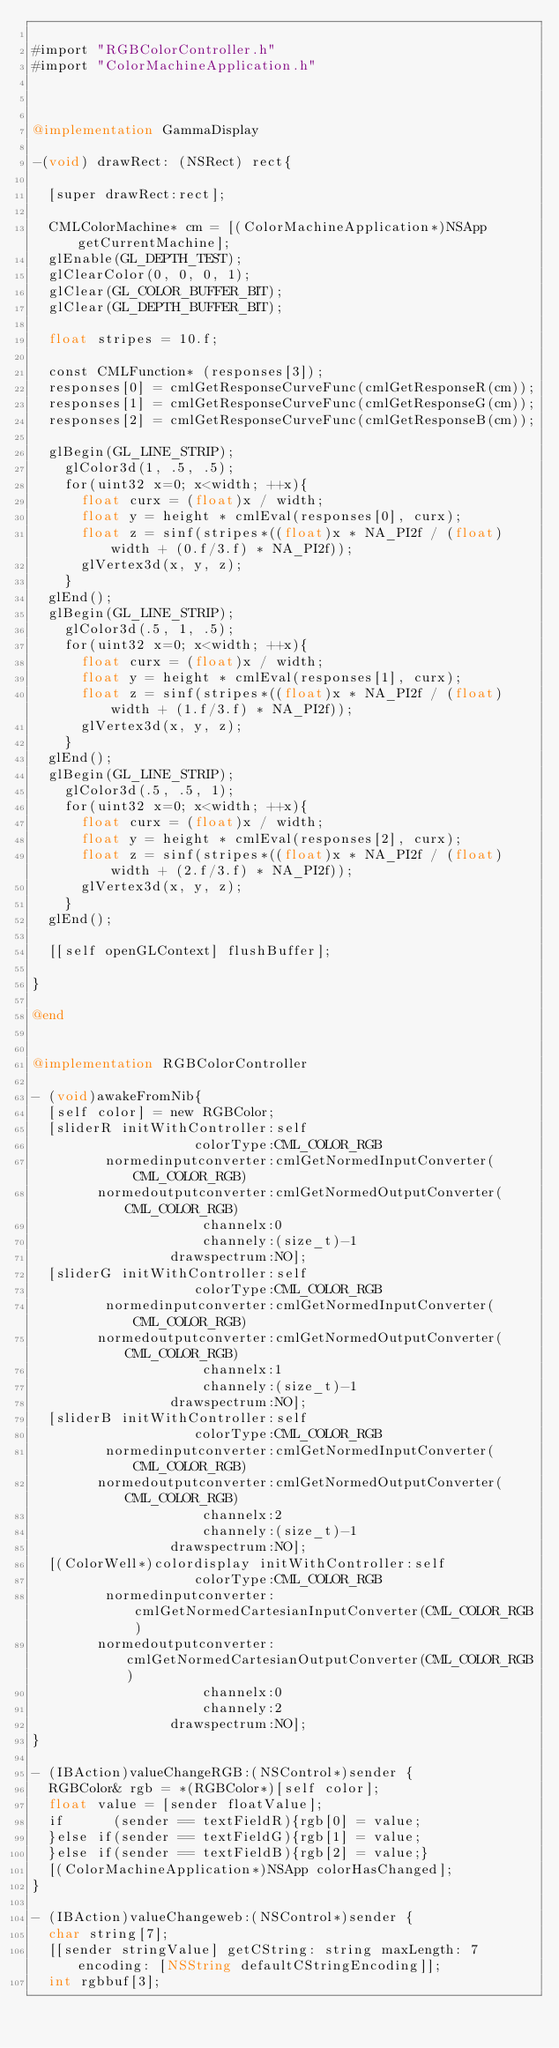Convert code to text. <code><loc_0><loc_0><loc_500><loc_500><_ObjectiveC_>
#import "RGBColorController.h"
#import "ColorMachineApplication.h"



@implementation GammaDisplay

-(void) drawRect: (NSRect) rect{
  
  [super drawRect:rect];

  CMLColorMachine* cm = [(ColorMachineApplication*)NSApp getCurrentMachine];
  glEnable(GL_DEPTH_TEST);
  glClearColor(0, 0, 0, 1);
  glClear(GL_COLOR_BUFFER_BIT);
  glClear(GL_DEPTH_BUFFER_BIT);

  float stripes = 10.f;

  const CMLFunction* (responses[3]);
  responses[0] = cmlGetResponseCurveFunc(cmlGetResponseR(cm));
  responses[1] = cmlGetResponseCurveFunc(cmlGetResponseG(cm));
  responses[2] = cmlGetResponseCurveFunc(cmlGetResponseB(cm));

  glBegin(GL_LINE_STRIP);
    glColor3d(1, .5, .5);
    for(uint32 x=0; x<width; ++x){
      float curx = (float)x / width;
      float y = height * cmlEval(responses[0], curx);
      float z = sinf(stripes*((float)x * NA_PI2f / (float)width + (0.f/3.f) * NA_PI2f));
      glVertex3d(x, y, z);
    }
  glEnd();
  glBegin(GL_LINE_STRIP);
    glColor3d(.5, 1, .5);
    for(uint32 x=0; x<width; ++x){
      float curx = (float)x / width;
      float y = height * cmlEval(responses[1], curx);
      float z = sinf(stripes*((float)x * NA_PI2f / (float)width + (1.f/3.f) * NA_PI2f));
      glVertex3d(x, y, z);
    }
  glEnd();
  glBegin(GL_LINE_STRIP);
    glColor3d(.5, .5, 1);
    for(uint32 x=0; x<width; ++x){
      float curx = (float)x / width;
      float y = height * cmlEval(responses[2], curx);
      float z = sinf(stripes*((float)x * NA_PI2f / (float)width + (2.f/3.f) * NA_PI2f));
      glVertex3d(x, y, z);
    }
  glEnd();

  [[self openGLContext] flushBuffer];

}

@end


@implementation RGBColorController

- (void)awakeFromNib{
  [self color] = new RGBColor;
  [sliderR initWithController:self
                    colorType:CML_COLOR_RGB
         normedinputconverter:cmlGetNormedInputConverter(CML_COLOR_RGB)
        normedoutputconverter:cmlGetNormedOutputConverter(CML_COLOR_RGB)
                     channelx:0
                     channely:(size_t)-1
                 drawspectrum:NO];
  [sliderG initWithController:self
                    colorType:CML_COLOR_RGB
         normedinputconverter:cmlGetNormedInputConverter(CML_COLOR_RGB)
        normedoutputconverter:cmlGetNormedOutputConverter(CML_COLOR_RGB)
                     channelx:1
                     channely:(size_t)-1
                 drawspectrum:NO];
  [sliderB initWithController:self
                    colorType:CML_COLOR_RGB
         normedinputconverter:cmlGetNormedInputConverter(CML_COLOR_RGB)
        normedoutputconverter:cmlGetNormedOutputConverter(CML_COLOR_RGB)
                     channelx:2
                     channely:(size_t)-1
                 drawspectrum:NO];
  [(ColorWell*)colordisplay initWithController:self
                    colorType:CML_COLOR_RGB
         normedinputconverter:cmlGetNormedCartesianInputConverter(CML_COLOR_RGB)
        normedoutputconverter:cmlGetNormedCartesianOutputConverter(CML_COLOR_RGB)
                     channelx:0
                     channely:2
                 drawspectrum:NO];
}

- (IBAction)valueChangeRGB:(NSControl*)sender {
  RGBColor& rgb = *(RGBColor*)[self color];
  float value = [sender floatValue];
  if      (sender == textFieldR){rgb[0] = value;
  }else if(sender == textFieldG){rgb[1] = value;
  }else if(sender == textFieldB){rgb[2] = value;}
  [(ColorMachineApplication*)NSApp colorHasChanged];
}

- (IBAction)valueChangeweb:(NSControl*)sender {
  char string[7];
  [[sender stringValue] getCString: string maxLength: 7 encoding: [NSString defaultCStringEncoding]];
  int rgbbuf[3];</code> 